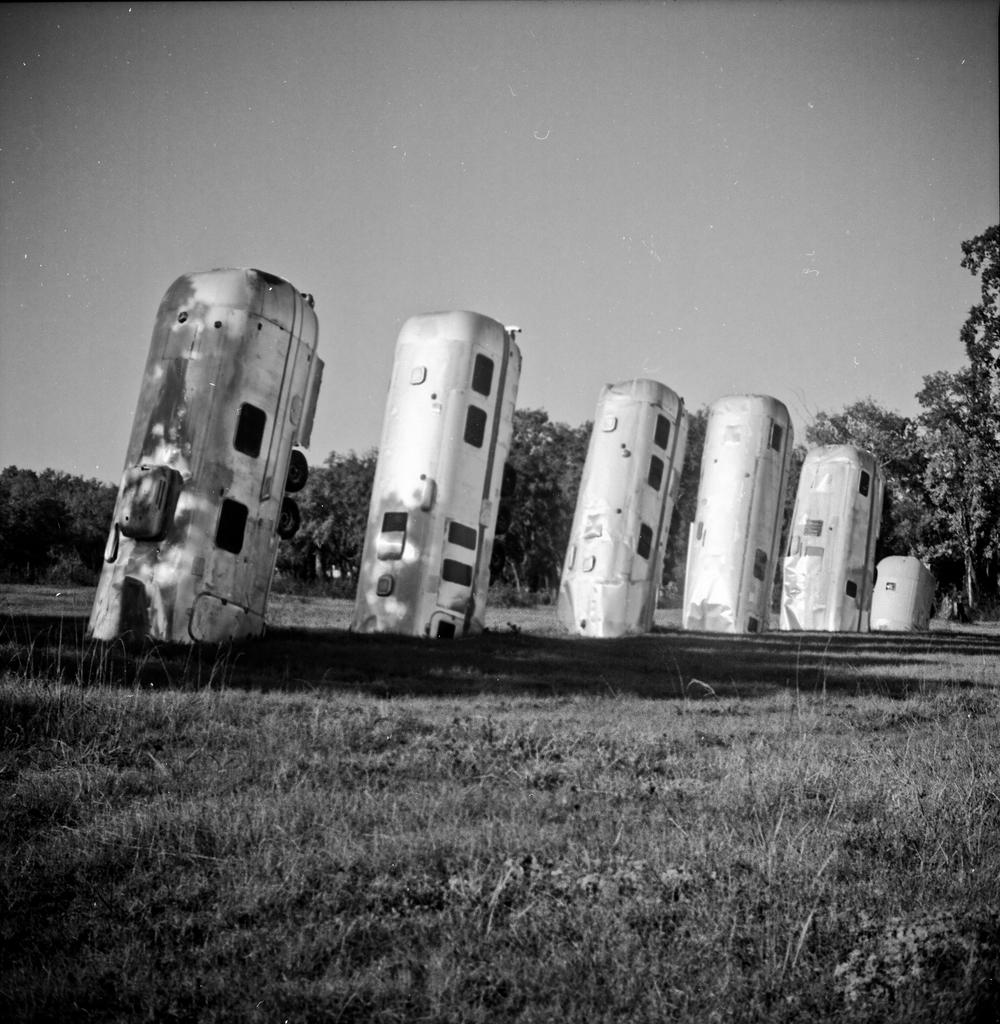What type of objects are partially buried in the image? There are vehicles in the image that are half in the ground. What can be seen in the background of the image? There are trees and a clear sky visible in the background of the image. What type of face can be seen on the vehicles in the image? There are no faces present on the vehicles in the image. How does the behavior of the vehicles change throughout the day in the image? The vehicles in the image are stationary and do not exhibit any behavior, as they are not living beings. 